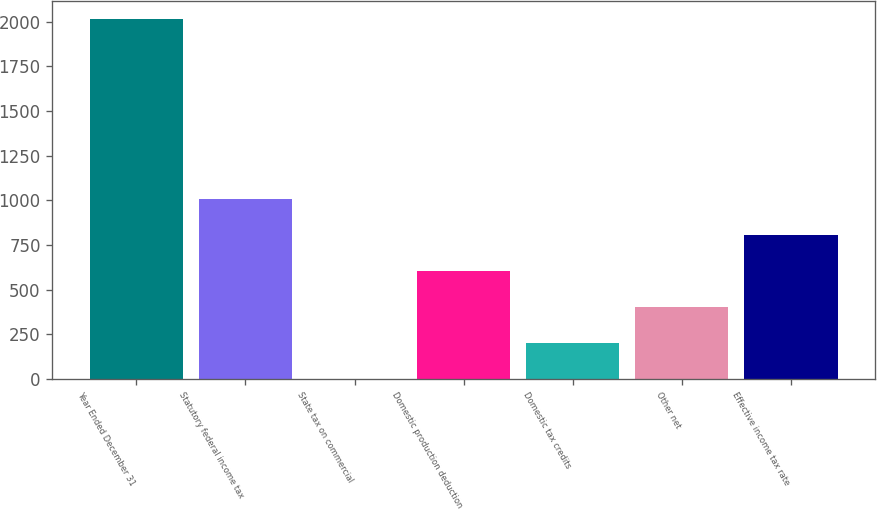<chart> <loc_0><loc_0><loc_500><loc_500><bar_chart><fcel>Year Ended December 31<fcel>Statutory federal income tax<fcel>State tax on commercial<fcel>Domestic production deduction<fcel>Domestic tax credits<fcel>Other net<fcel>Effective income tax rate<nl><fcel>2013<fcel>1006.85<fcel>0.7<fcel>604.39<fcel>201.93<fcel>403.16<fcel>805.62<nl></chart> 